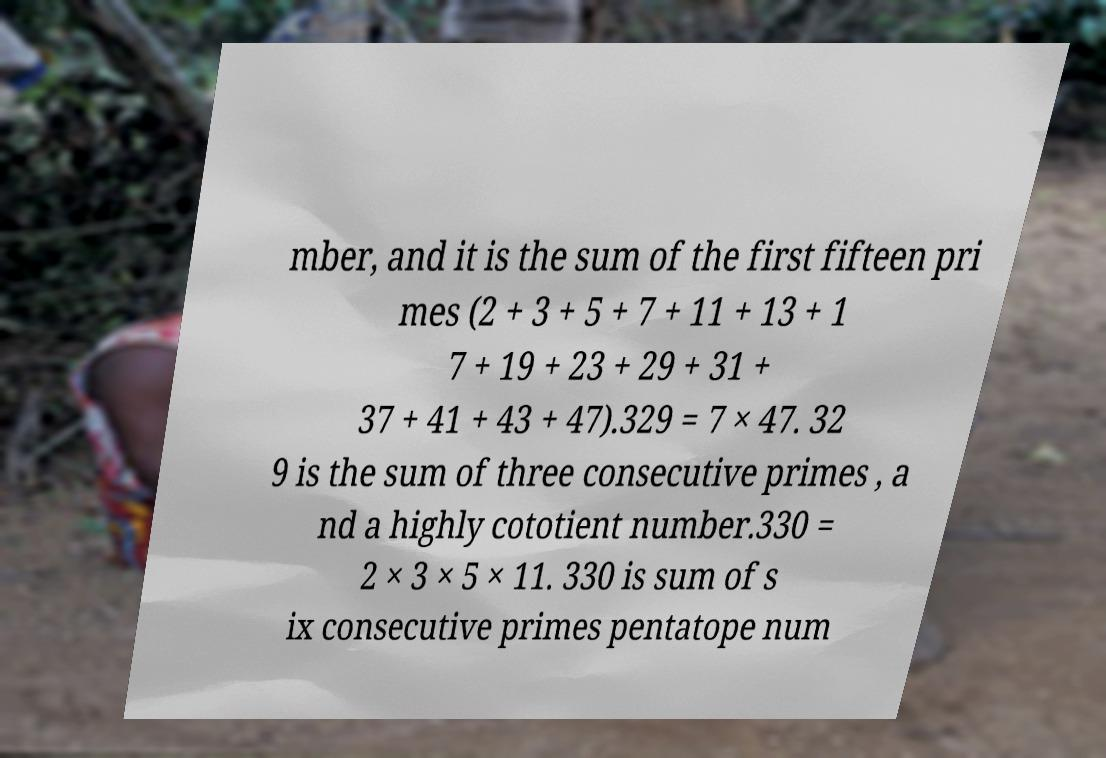Could you extract and type out the text from this image? mber, and it is the sum of the first fifteen pri mes (2 + 3 + 5 + 7 + 11 + 13 + 1 7 + 19 + 23 + 29 + 31 + 37 + 41 + 43 + 47).329 = 7 × 47. 32 9 is the sum of three consecutive primes , a nd a highly cototient number.330 = 2 × 3 × 5 × 11. 330 is sum of s ix consecutive primes pentatope num 